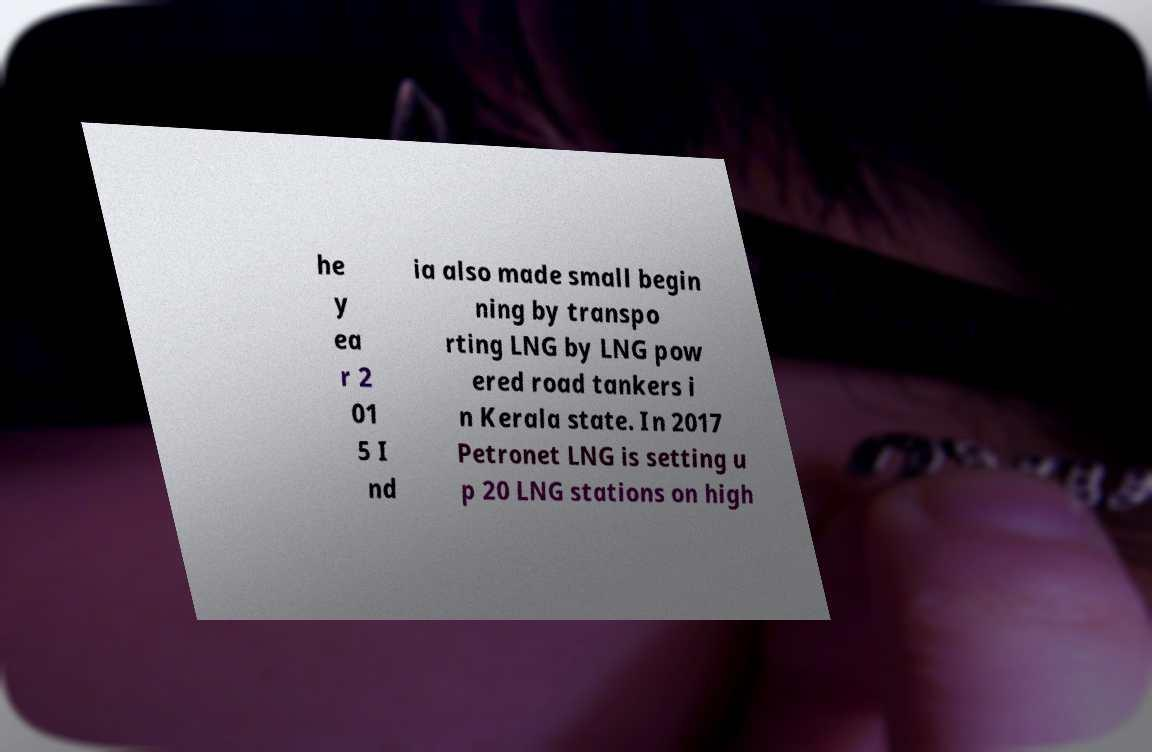I need the written content from this picture converted into text. Can you do that? he y ea r 2 01 5 I nd ia also made small begin ning by transpo rting LNG by LNG pow ered road tankers i n Kerala state. In 2017 Petronet LNG is setting u p 20 LNG stations on high 